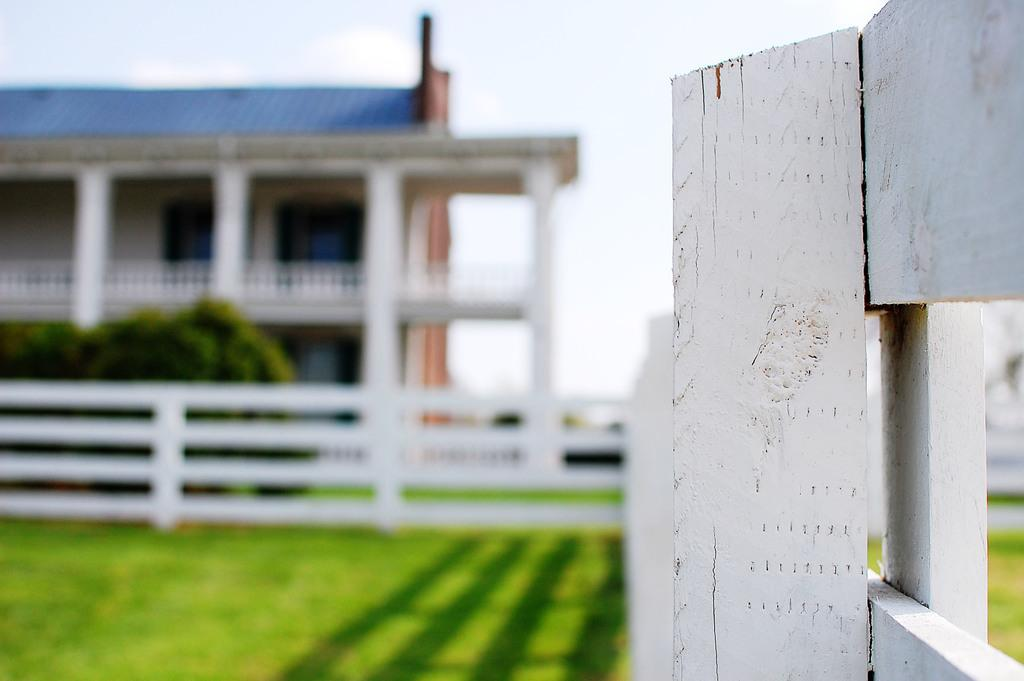What type of fencing is visible on the right side of the image? There is wooden fencing on the right side of the image. What structure is located on the left side of the image? There is a building on the left side of the image. What type of vegetation can be seen in the image? There are trees and grass in the image. Where is the second instance of wooden fencing located in the image? There is wooden fencing in the middle of the image. What part of the natural environment is visible in the image? The sky is visible in the image. How many cacti are present in the image? There are no cacti present in the image. What type of lock is used on the wooden fencing in the image? There is no lock visible on the wooden fencing in the image. 